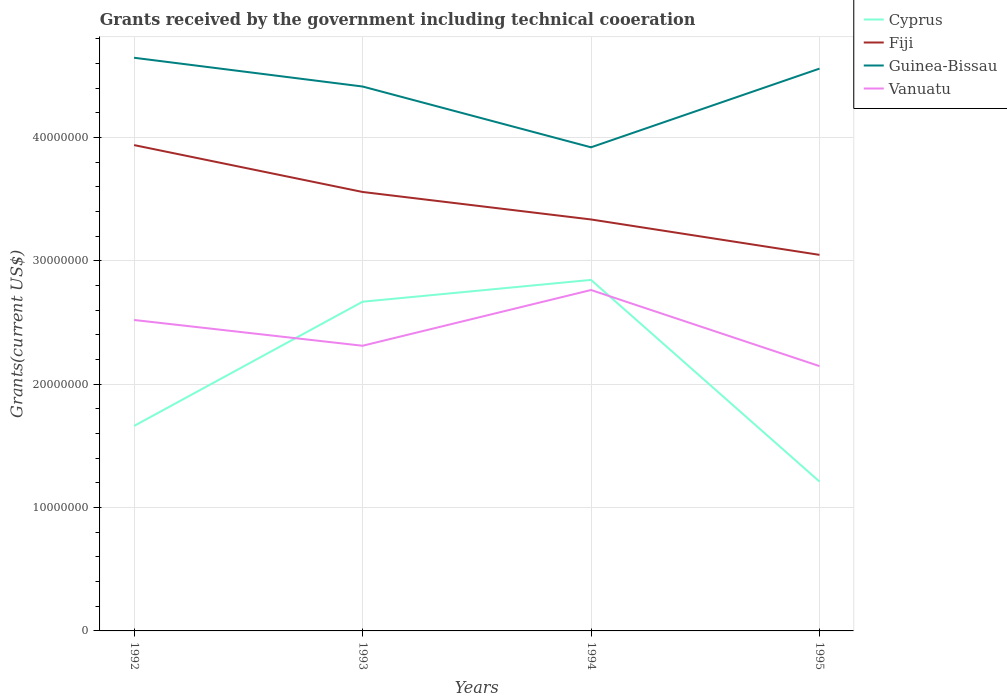How many different coloured lines are there?
Ensure brevity in your answer.  4. Does the line corresponding to Fiji intersect with the line corresponding to Cyprus?
Make the answer very short. No. Across all years, what is the maximum total grants received by the government in Vanuatu?
Your answer should be very brief. 2.15e+07. In which year was the total grants received by the government in Guinea-Bissau maximum?
Your response must be concise. 1994. What is the total total grants received by the government in Guinea-Bissau in the graph?
Offer a very short reply. 4.93e+06. What is the difference between the highest and the second highest total grants received by the government in Vanuatu?
Offer a terse response. 6.17e+06. What is the difference between the highest and the lowest total grants received by the government in Vanuatu?
Ensure brevity in your answer.  2. Is the total grants received by the government in Cyprus strictly greater than the total grants received by the government in Vanuatu over the years?
Provide a short and direct response. No. How many lines are there?
Give a very brief answer. 4. How many years are there in the graph?
Your answer should be very brief. 4. Are the values on the major ticks of Y-axis written in scientific E-notation?
Give a very brief answer. No. Does the graph contain any zero values?
Offer a very short reply. No. Where does the legend appear in the graph?
Provide a short and direct response. Top right. How many legend labels are there?
Ensure brevity in your answer.  4. How are the legend labels stacked?
Your answer should be compact. Vertical. What is the title of the graph?
Your answer should be very brief. Grants received by the government including technical cooeration. What is the label or title of the X-axis?
Keep it short and to the point. Years. What is the label or title of the Y-axis?
Your response must be concise. Grants(current US$). What is the Grants(current US$) in Cyprus in 1992?
Your answer should be very brief. 1.66e+07. What is the Grants(current US$) of Fiji in 1992?
Your response must be concise. 3.94e+07. What is the Grants(current US$) of Guinea-Bissau in 1992?
Offer a very short reply. 4.65e+07. What is the Grants(current US$) of Vanuatu in 1992?
Your answer should be compact. 2.52e+07. What is the Grants(current US$) in Cyprus in 1993?
Make the answer very short. 2.67e+07. What is the Grants(current US$) in Fiji in 1993?
Give a very brief answer. 3.56e+07. What is the Grants(current US$) in Guinea-Bissau in 1993?
Offer a terse response. 4.41e+07. What is the Grants(current US$) of Vanuatu in 1993?
Provide a succinct answer. 2.31e+07. What is the Grants(current US$) in Cyprus in 1994?
Your response must be concise. 2.85e+07. What is the Grants(current US$) of Fiji in 1994?
Provide a succinct answer. 3.34e+07. What is the Grants(current US$) of Guinea-Bissau in 1994?
Give a very brief answer. 3.92e+07. What is the Grants(current US$) of Vanuatu in 1994?
Your response must be concise. 2.76e+07. What is the Grants(current US$) in Cyprus in 1995?
Provide a short and direct response. 1.21e+07. What is the Grants(current US$) of Fiji in 1995?
Offer a terse response. 3.05e+07. What is the Grants(current US$) of Guinea-Bissau in 1995?
Provide a short and direct response. 4.56e+07. What is the Grants(current US$) in Vanuatu in 1995?
Offer a terse response. 2.15e+07. Across all years, what is the maximum Grants(current US$) in Cyprus?
Offer a very short reply. 2.85e+07. Across all years, what is the maximum Grants(current US$) in Fiji?
Your response must be concise. 3.94e+07. Across all years, what is the maximum Grants(current US$) of Guinea-Bissau?
Your answer should be very brief. 4.65e+07. Across all years, what is the maximum Grants(current US$) of Vanuatu?
Provide a succinct answer. 2.76e+07. Across all years, what is the minimum Grants(current US$) of Cyprus?
Ensure brevity in your answer.  1.21e+07. Across all years, what is the minimum Grants(current US$) of Fiji?
Offer a very short reply. 3.05e+07. Across all years, what is the minimum Grants(current US$) in Guinea-Bissau?
Give a very brief answer. 3.92e+07. Across all years, what is the minimum Grants(current US$) in Vanuatu?
Keep it short and to the point. 2.15e+07. What is the total Grants(current US$) of Cyprus in the graph?
Your response must be concise. 8.39e+07. What is the total Grants(current US$) in Fiji in the graph?
Keep it short and to the point. 1.39e+08. What is the total Grants(current US$) of Guinea-Bissau in the graph?
Your answer should be compact. 1.75e+08. What is the total Grants(current US$) in Vanuatu in the graph?
Your response must be concise. 9.74e+07. What is the difference between the Grants(current US$) of Cyprus in 1992 and that in 1993?
Make the answer very short. -1.01e+07. What is the difference between the Grants(current US$) in Fiji in 1992 and that in 1993?
Give a very brief answer. 3.80e+06. What is the difference between the Grants(current US$) of Guinea-Bissau in 1992 and that in 1993?
Offer a very short reply. 2.33e+06. What is the difference between the Grants(current US$) of Vanuatu in 1992 and that in 1993?
Provide a short and direct response. 2.09e+06. What is the difference between the Grants(current US$) in Cyprus in 1992 and that in 1994?
Make the answer very short. -1.18e+07. What is the difference between the Grants(current US$) of Fiji in 1992 and that in 1994?
Provide a succinct answer. 6.03e+06. What is the difference between the Grants(current US$) in Guinea-Bissau in 1992 and that in 1994?
Keep it short and to the point. 7.26e+06. What is the difference between the Grants(current US$) in Vanuatu in 1992 and that in 1994?
Ensure brevity in your answer.  -2.43e+06. What is the difference between the Grants(current US$) in Cyprus in 1992 and that in 1995?
Your answer should be very brief. 4.51e+06. What is the difference between the Grants(current US$) of Fiji in 1992 and that in 1995?
Your answer should be very brief. 8.90e+06. What is the difference between the Grants(current US$) in Guinea-Bissau in 1992 and that in 1995?
Offer a terse response. 8.80e+05. What is the difference between the Grants(current US$) in Vanuatu in 1992 and that in 1995?
Your response must be concise. 3.74e+06. What is the difference between the Grants(current US$) in Cyprus in 1993 and that in 1994?
Make the answer very short. -1.77e+06. What is the difference between the Grants(current US$) of Fiji in 1993 and that in 1994?
Your response must be concise. 2.23e+06. What is the difference between the Grants(current US$) of Guinea-Bissau in 1993 and that in 1994?
Make the answer very short. 4.93e+06. What is the difference between the Grants(current US$) in Vanuatu in 1993 and that in 1994?
Make the answer very short. -4.52e+06. What is the difference between the Grants(current US$) in Cyprus in 1993 and that in 1995?
Provide a succinct answer. 1.46e+07. What is the difference between the Grants(current US$) of Fiji in 1993 and that in 1995?
Your answer should be very brief. 5.10e+06. What is the difference between the Grants(current US$) of Guinea-Bissau in 1993 and that in 1995?
Offer a terse response. -1.45e+06. What is the difference between the Grants(current US$) of Vanuatu in 1993 and that in 1995?
Your answer should be very brief. 1.65e+06. What is the difference between the Grants(current US$) in Cyprus in 1994 and that in 1995?
Provide a short and direct response. 1.64e+07. What is the difference between the Grants(current US$) of Fiji in 1994 and that in 1995?
Provide a short and direct response. 2.87e+06. What is the difference between the Grants(current US$) of Guinea-Bissau in 1994 and that in 1995?
Provide a short and direct response. -6.38e+06. What is the difference between the Grants(current US$) in Vanuatu in 1994 and that in 1995?
Your answer should be compact. 6.17e+06. What is the difference between the Grants(current US$) of Cyprus in 1992 and the Grants(current US$) of Fiji in 1993?
Make the answer very short. -1.90e+07. What is the difference between the Grants(current US$) of Cyprus in 1992 and the Grants(current US$) of Guinea-Bissau in 1993?
Keep it short and to the point. -2.75e+07. What is the difference between the Grants(current US$) in Cyprus in 1992 and the Grants(current US$) in Vanuatu in 1993?
Give a very brief answer. -6.50e+06. What is the difference between the Grants(current US$) in Fiji in 1992 and the Grants(current US$) in Guinea-Bissau in 1993?
Ensure brevity in your answer.  -4.75e+06. What is the difference between the Grants(current US$) in Fiji in 1992 and the Grants(current US$) in Vanuatu in 1993?
Offer a terse response. 1.63e+07. What is the difference between the Grants(current US$) in Guinea-Bissau in 1992 and the Grants(current US$) in Vanuatu in 1993?
Your response must be concise. 2.34e+07. What is the difference between the Grants(current US$) of Cyprus in 1992 and the Grants(current US$) of Fiji in 1994?
Keep it short and to the point. -1.67e+07. What is the difference between the Grants(current US$) of Cyprus in 1992 and the Grants(current US$) of Guinea-Bissau in 1994?
Offer a terse response. -2.26e+07. What is the difference between the Grants(current US$) of Cyprus in 1992 and the Grants(current US$) of Vanuatu in 1994?
Your answer should be compact. -1.10e+07. What is the difference between the Grants(current US$) in Fiji in 1992 and the Grants(current US$) in Vanuatu in 1994?
Your answer should be compact. 1.18e+07. What is the difference between the Grants(current US$) of Guinea-Bissau in 1992 and the Grants(current US$) of Vanuatu in 1994?
Ensure brevity in your answer.  1.88e+07. What is the difference between the Grants(current US$) in Cyprus in 1992 and the Grants(current US$) in Fiji in 1995?
Provide a succinct answer. -1.39e+07. What is the difference between the Grants(current US$) in Cyprus in 1992 and the Grants(current US$) in Guinea-Bissau in 1995?
Your answer should be very brief. -2.90e+07. What is the difference between the Grants(current US$) in Cyprus in 1992 and the Grants(current US$) in Vanuatu in 1995?
Offer a terse response. -4.85e+06. What is the difference between the Grants(current US$) of Fiji in 1992 and the Grants(current US$) of Guinea-Bissau in 1995?
Give a very brief answer. -6.20e+06. What is the difference between the Grants(current US$) in Fiji in 1992 and the Grants(current US$) in Vanuatu in 1995?
Keep it short and to the point. 1.79e+07. What is the difference between the Grants(current US$) in Guinea-Bissau in 1992 and the Grants(current US$) in Vanuatu in 1995?
Your answer should be compact. 2.50e+07. What is the difference between the Grants(current US$) in Cyprus in 1993 and the Grants(current US$) in Fiji in 1994?
Make the answer very short. -6.67e+06. What is the difference between the Grants(current US$) of Cyprus in 1993 and the Grants(current US$) of Guinea-Bissau in 1994?
Your answer should be compact. -1.25e+07. What is the difference between the Grants(current US$) of Cyprus in 1993 and the Grants(current US$) of Vanuatu in 1994?
Give a very brief answer. -9.50e+05. What is the difference between the Grants(current US$) of Fiji in 1993 and the Grants(current US$) of Guinea-Bissau in 1994?
Provide a succinct answer. -3.62e+06. What is the difference between the Grants(current US$) in Fiji in 1993 and the Grants(current US$) in Vanuatu in 1994?
Make the answer very short. 7.95e+06. What is the difference between the Grants(current US$) in Guinea-Bissau in 1993 and the Grants(current US$) in Vanuatu in 1994?
Your response must be concise. 1.65e+07. What is the difference between the Grants(current US$) in Cyprus in 1993 and the Grants(current US$) in Fiji in 1995?
Give a very brief answer. -3.80e+06. What is the difference between the Grants(current US$) in Cyprus in 1993 and the Grants(current US$) in Guinea-Bissau in 1995?
Give a very brief answer. -1.89e+07. What is the difference between the Grants(current US$) of Cyprus in 1993 and the Grants(current US$) of Vanuatu in 1995?
Keep it short and to the point. 5.22e+06. What is the difference between the Grants(current US$) of Fiji in 1993 and the Grants(current US$) of Guinea-Bissau in 1995?
Your answer should be very brief. -1.00e+07. What is the difference between the Grants(current US$) in Fiji in 1993 and the Grants(current US$) in Vanuatu in 1995?
Ensure brevity in your answer.  1.41e+07. What is the difference between the Grants(current US$) of Guinea-Bissau in 1993 and the Grants(current US$) of Vanuatu in 1995?
Provide a succinct answer. 2.27e+07. What is the difference between the Grants(current US$) of Cyprus in 1994 and the Grants(current US$) of Fiji in 1995?
Ensure brevity in your answer.  -2.03e+06. What is the difference between the Grants(current US$) in Cyprus in 1994 and the Grants(current US$) in Guinea-Bissau in 1995?
Make the answer very short. -1.71e+07. What is the difference between the Grants(current US$) of Cyprus in 1994 and the Grants(current US$) of Vanuatu in 1995?
Offer a terse response. 6.99e+06. What is the difference between the Grants(current US$) in Fiji in 1994 and the Grants(current US$) in Guinea-Bissau in 1995?
Keep it short and to the point. -1.22e+07. What is the difference between the Grants(current US$) of Fiji in 1994 and the Grants(current US$) of Vanuatu in 1995?
Offer a terse response. 1.19e+07. What is the difference between the Grants(current US$) in Guinea-Bissau in 1994 and the Grants(current US$) in Vanuatu in 1995?
Offer a very short reply. 1.77e+07. What is the average Grants(current US$) of Cyprus per year?
Offer a terse response. 2.10e+07. What is the average Grants(current US$) of Fiji per year?
Provide a short and direct response. 3.47e+07. What is the average Grants(current US$) in Guinea-Bissau per year?
Your answer should be compact. 4.39e+07. What is the average Grants(current US$) in Vanuatu per year?
Make the answer very short. 2.44e+07. In the year 1992, what is the difference between the Grants(current US$) in Cyprus and Grants(current US$) in Fiji?
Keep it short and to the point. -2.28e+07. In the year 1992, what is the difference between the Grants(current US$) in Cyprus and Grants(current US$) in Guinea-Bissau?
Make the answer very short. -2.98e+07. In the year 1992, what is the difference between the Grants(current US$) in Cyprus and Grants(current US$) in Vanuatu?
Ensure brevity in your answer.  -8.59e+06. In the year 1992, what is the difference between the Grants(current US$) of Fiji and Grants(current US$) of Guinea-Bissau?
Ensure brevity in your answer.  -7.08e+06. In the year 1992, what is the difference between the Grants(current US$) in Fiji and Grants(current US$) in Vanuatu?
Ensure brevity in your answer.  1.42e+07. In the year 1992, what is the difference between the Grants(current US$) in Guinea-Bissau and Grants(current US$) in Vanuatu?
Your answer should be compact. 2.13e+07. In the year 1993, what is the difference between the Grants(current US$) in Cyprus and Grants(current US$) in Fiji?
Provide a succinct answer. -8.90e+06. In the year 1993, what is the difference between the Grants(current US$) in Cyprus and Grants(current US$) in Guinea-Bissau?
Offer a terse response. -1.74e+07. In the year 1993, what is the difference between the Grants(current US$) in Cyprus and Grants(current US$) in Vanuatu?
Your response must be concise. 3.57e+06. In the year 1993, what is the difference between the Grants(current US$) of Fiji and Grants(current US$) of Guinea-Bissau?
Make the answer very short. -8.55e+06. In the year 1993, what is the difference between the Grants(current US$) of Fiji and Grants(current US$) of Vanuatu?
Your answer should be very brief. 1.25e+07. In the year 1993, what is the difference between the Grants(current US$) of Guinea-Bissau and Grants(current US$) of Vanuatu?
Offer a very short reply. 2.10e+07. In the year 1994, what is the difference between the Grants(current US$) in Cyprus and Grants(current US$) in Fiji?
Your answer should be very brief. -4.90e+06. In the year 1994, what is the difference between the Grants(current US$) in Cyprus and Grants(current US$) in Guinea-Bissau?
Offer a terse response. -1.08e+07. In the year 1994, what is the difference between the Grants(current US$) of Cyprus and Grants(current US$) of Vanuatu?
Keep it short and to the point. 8.20e+05. In the year 1994, what is the difference between the Grants(current US$) in Fiji and Grants(current US$) in Guinea-Bissau?
Provide a succinct answer. -5.85e+06. In the year 1994, what is the difference between the Grants(current US$) in Fiji and Grants(current US$) in Vanuatu?
Provide a short and direct response. 5.72e+06. In the year 1994, what is the difference between the Grants(current US$) of Guinea-Bissau and Grants(current US$) of Vanuatu?
Ensure brevity in your answer.  1.16e+07. In the year 1995, what is the difference between the Grants(current US$) of Cyprus and Grants(current US$) of Fiji?
Provide a short and direct response. -1.84e+07. In the year 1995, what is the difference between the Grants(current US$) of Cyprus and Grants(current US$) of Guinea-Bissau?
Your answer should be compact. -3.35e+07. In the year 1995, what is the difference between the Grants(current US$) of Cyprus and Grants(current US$) of Vanuatu?
Your answer should be compact. -9.36e+06. In the year 1995, what is the difference between the Grants(current US$) in Fiji and Grants(current US$) in Guinea-Bissau?
Offer a very short reply. -1.51e+07. In the year 1995, what is the difference between the Grants(current US$) of Fiji and Grants(current US$) of Vanuatu?
Provide a succinct answer. 9.02e+06. In the year 1995, what is the difference between the Grants(current US$) of Guinea-Bissau and Grants(current US$) of Vanuatu?
Offer a terse response. 2.41e+07. What is the ratio of the Grants(current US$) of Cyprus in 1992 to that in 1993?
Ensure brevity in your answer.  0.62. What is the ratio of the Grants(current US$) of Fiji in 1992 to that in 1993?
Your answer should be compact. 1.11. What is the ratio of the Grants(current US$) of Guinea-Bissau in 1992 to that in 1993?
Your response must be concise. 1.05. What is the ratio of the Grants(current US$) of Vanuatu in 1992 to that in 1993?
Give a very brief answer. 1.09. What is the ratio of the Grants(current US$) in Cyprus in 1992 to that in 1994?
Make the answer very short. 0.58. What is the ratio of the Grants(current US$) of Fiji in 1992 to that in 1994?
Your answer should be compact. 1.18. What is the ratio of the Grants(current US$) in Guinea-Bissau in 1992 to that in 1994?
Provide a short and direct response. 1.19. What is the ratio of the Grants(current US$) in Vanuatu in 1992 to that in 1994?
Give a very brief answer. 0.91. What is the ratio of the Grants(current US$) in Cyprus in 1992 to that in 1995?
Make the answer very short. 1.37. What is the ratio of the Grants(current US$) in Fiji in 1992 to that in 1995?
Provide a succinct answer. 1.29. What is the ratio of the Grants(current US$) of Guinea-Bissau in 1992 to that in 1995?
Offer a very short reply. 1.02. What is the ratio of the Grants(current US$) of Vanuatu in 1992 to that in 1995?
Your response must be concise. 1.17. What is the ratio of the Grants(current US$) of Cyprus in 1993 to that in 1994?
Offer a terse response. 0.94. What is the ratio of the Grants(current US$) of Fiji in 1993 to that in 1994?
Offer a very short reply. 1.07. What is the ratio of the Grants(current US$) of Guinea-Bissau in 1993 to that in 1994?
Provide a succinct answer. 1.13. What is the ratio of the Grants(current US$) of Vanuatu in 1993 to that in 1994?
Ensure brevity in your answer.  0.84. What is the ratio of the Grants(current US$) in Cyprus in 1993 to that in 1995?
Provide a short and direct response. 2.2. What is the ratio of the Grants(current US$) of Fiji in 1993 to that in 1995?
Your response must be concise. 1.17. What is the ratio of the Grants(current US$) in Guinea-Bissau in 1993 to that in 1995?
Offer a terse response. 0.97. What is the ratio of the Grants(current US$) in Cyprus in 1994 to that in 1995?
Ensure brevity in your answer.  2.35. What is the ratio of the Grants(current US$) in Fiji in 1994 to that in 1995?
Your response must be concise. 1.09. What is the ratio of the Grants(current US$) in Guinea-Bissau in 1994 to that in 1995?
Ensure brevity in your answer.  0.86. What is the ratio of the Grants(current US$) of Vanuatu in 1994 to that in 1995?
Give a very brief answer. 1.29. What is the difference between the highest and the second highest Grants(current US$) of Cyprus?
Your answer should be compact. 1.77e+06. What is the difference between the highest and the second highest Grants(current US$) in Fiji?
Ensure brevity in your answer.  3.80e+06. What is the difference between the highest and the second highest Grants(current US$) in Guinea-Bissau?
Your answer should be compact. 8.80e+05. What is the difference between the highest and the second highest Grants(current US$) of Vanuatu?
Provide a short and direct response. 2.43e+06. What is the difference between the highest and the lowest Grants(current US$) in Cyprus?
Your answer should be compact. 1.64e+07. What is the difference between the highest and the lowest Grants(current US$) in Fiji?
Your response must be concise. 8.90e+06. What is the difference between the highest and the lowest Grants(current US$) in Guinea-Bissau?
Provide a succinct answer. 7.26e+06. What is the difference between the highest and the lowest Grants(current US$) of Vanuatu?
Keep it short and to the point. 6.17e+06. 